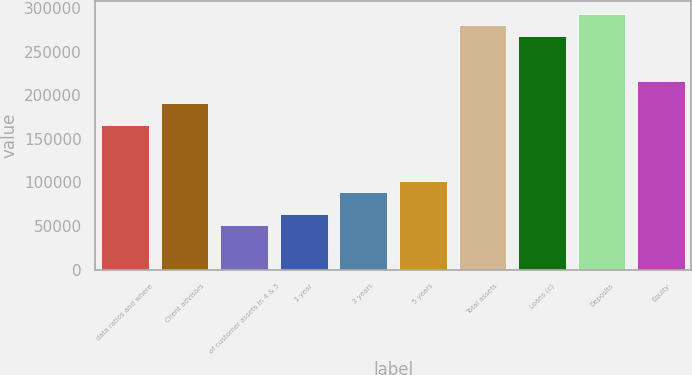<chart> <loc_0><loc_0><loc_500><loc_500><bar_chart><fcel>data ratios and where<fcel>Client advisors<fcel>of customer assets in 4 & 5<fcel>1 year<fcel>3 years<fcel>5 years<fcel>Total assets<fcel>Loans (c)<fcel>Deposits<fcel>Equity<nl><fcel>165703<fcel>191196<fcel>50985.7<fcel>63732.1<fcel>89224.8<fcel>101971<fcel>280421<fcel>267674<fcel>293167<fcel>216689<nl></chart> 